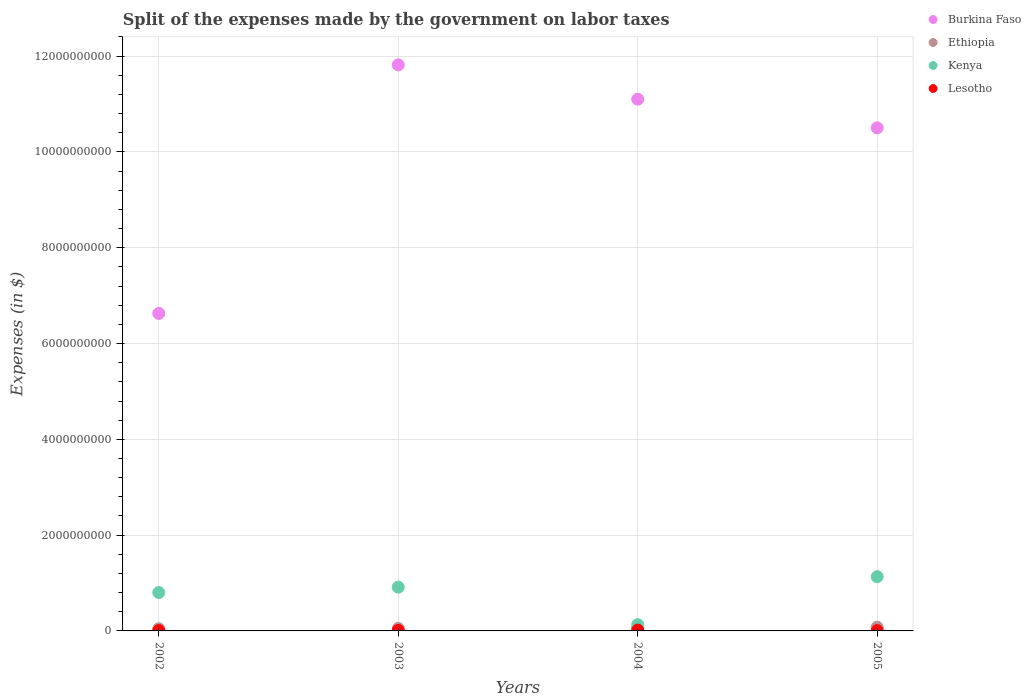How many different coloured dotlines are there?
Provide a short and direct response. 4. What is the expenses made by the government on labor taxes in Kenya in 2003?
Give a very brief answer. 9.14e+08. Across all years, what is the maximum expenses made by the government on labor taxes in Ethiopia?
Make the answer very short. 7.71e+07. Across all years, what is the minimum expenses made by the government on labor taxes in Burkina Faso?
Provide a succinct answer. 6.63e+09. In which year was the expenses made by the government on labor taxes in Ethiopia minimum?
Make the answer very short. 2002. What is the total expenses made by the government on labor taxes in Kenya in the graph?
Provide a succinct answer. 2.98e+09. What is the difference between the expenses made by the government on labor taxes in Ethiopia in 2003 and that in 2004?
Your response must be concise. -5.10e+06. What is the difference between the expenses made by the government on labor taxes in Ethiopia in 2002 and the expenses made by the government on labor taxes in Lesotho in 2003?
Give a very brief answer. 3.46e+07. What is the average expenses made by the government on labor taxes in Lesotho per year?
Your answer should be very brief. 1.04e+07. In the year 2003, what is the difference between the expenses made by the government on labor taxes in Ethiopia and expenses made by the government on labor taxes in Kenya?
Your answer should be very brief. -8.62e+08. In how many years, is the expenses made by the government on labor taxes in Lesotho greater than 1600000000 $?
Ensure brevity in your answer.  0. What is the ratio of the expenses made by the government on labor taxes in Lesotho in 2002 to that in 2005?
Your answer should be compact. 0.95. What is the difference between the highest and the lowest expenses made by the government on labor taxes in Burkina Faso?
Provide a succinct answer. 5.19e+09. In how many years, is the expenses made by the government on labor taxes in Lesotho greater than the average expenses made by the government on labor taxes in Lesotho taken over all years?
Provide a short and direct response. 2. Is it the case that in every year, the sum of the expenses made by the government on labor taxes in Kenya and expenses made by the government on labor taxes in Burkina Faso  is greater than the sum of expenses made by the government on labor taxes in Ethiopia and expenses made by the government on labor taxes in Lesotho?
Provide a succinct answer. Yes. Does the expenses made by the government on labor taxes in Lesotho monotonically increase over the years?
Give a very brief answer. No. Is the expenses made by the government on labor taxes in Kenya strictly less than the expenses made by the government on labor taxes in Lesotho over the years?
Your answer should be very brief. No. What is the difference between two consecutive major ticks on the Y-axis?
Offer a very short reply. 2.00e+09. Does the graph contain any zero values?
Give a very brief answer. No. How are the legend labels stacked?
Your answer should be very brief. Vertical. What is the title of the graph?
Your answer should be very brief. Split of the expenses made by the government on labor taxes. Does "Virgin Islands" appear as one of the legend labels in the graph?
Make the answer very short. No. What is the label or title of the X-axis?
Make the answer very short. Years. What is the label or title of the Y-axis?
Make the answer very short. Expenses (in $). What is the Expenses (in $) of Burkina Faso in 2002?
Ensure brevity in your answer.  6.63e+09. What is the Expenses (in $) of Ethiopia in 2002?
Provide a short and direct response. 4.51e+07. What is the Expenses (in $) in Kenya in 2002?
Offer a terse response. 8.01e+08. What is the Expenses (in $) in Lesotho in 2002?
Your response must be concise. 6.40e+06. What is the Expenses (in $) of Burkina Faso in 2003?
Provide a succinct answer. 1.18e+1. What is the Expenses (in $) in Ethiopia in 2003?
Your answer should be very brief. 5.20e+07. What is the Expenses (in $) of Kenya in 2003?
Your answer should be compact. 9.14e+08. What is the Expenses (in $) of Lesotho in 2003?
Your answer should be compact. 1.05e+07. What is the Expenses (in $) of Burkina Faso in 2004?
Ensure brevity in your answer.  1.11e+1. What is the Expenses (in $) of Ethiopia in 2004?
Provide a short and direct response. 5.71e+07. What is the Expenses (in $) of Kenya in 2004?
Your answer should be compact. 1.31e+08. What is the Expenses (in $) in Lesotho in 2004?
Provide a short and direct response. 1.78e+07. What is the Expenses (in $) in Burkina Faso in 2005?
Make the answer very short. 1.05e+1. What is the Expenses (in $) of Ethiopia in 2005?
Make the answer very short. 7.71e+07. What is the Expenses (in $) in Kenya in 2005?
Offer a terse response. 1.13e+09. What is the Expenses (in $) in Lesotho in 2005?
Provide a short and direct response. 6.74e+06. Across all years, what is the maximum Expenses (in $) of Burkina Faso?
Provide a short and direct response. 1.18e+1. Across all years, what is the maximum Expenses (in $) of Ethiopia?
Make the answer very short. 7.71e+07. Across all years, what is the maximum Expenses (in $) in Kenya?
Provide a short and direct response. 1.13e+09. Across all years, what is the maximum Expenses (in $) in Lesotho?
Offer a terse response. 1.78e+07. Across all years, what is the minimum Expenses (in $) of Burkina Faso?
Provide a succinct answer. 6.63e+09. Across all years, what is the minimum Expenses (in $) in Ethiopia?
Your answer should be compact. 4.51e+07. Across all years, what is the minimum Expenses (in $) in Kenya?
Give a very brief answer. 1.31e+08. Across all years, what is the minimum Expenses (in $) of Lesotho?
Give a very brief answer. 6.40e+06. What is the total Expenses (in $) of Burkina Faso in the graph?
Provide a succinct answer. 4.01e+1. What is the total Expenses (in $) of Ethiopia in the graph?
Offer a terse response. 2.31e+08. What is the total Expenses (in $) in Kenya in the graph?
Your answer should be very brief. 2.98e+09. What is the total Expenses (in $) in Lesotho in the graph?
Ensure brevity in your answer.  4.14e+07. What is the difference between the Expenses (in $) in Burkina Faso in 2002 and that in 2003?
Provide a short and direct response. -5.19e+09. What is the difference between the Expenses (in $) in Ethiopia in 2002 and that in 2003?
Provide a succinct answer. -6.90e+06. What is the difference between the Expenses (in $) of Kenya in 2002 and that in 2003?
Provide a succinct answer. -1.13e+08. What is the difference between the Expenses (in $) of Lesotho in 2002 and that in 2003?
Provide a short and direct response. -4.08e+06. What is the difference between the Expenses (in $) in Burkina Faso in 2002 and that in 2004?
Your answer should be compact. -4.47e+09. What is the difference between the Expenses (in $) of Ethiopia in 2002 and that in 2004?
Your answer should be very brief. -1.20e+07. What is the difference between the Expenses (in $) of Kenya in 2002 and that in 2004?
Ensure brevity in your answer.  6.70e+08. What is the difference between the Expenses (in $) in Lesotho in 2002 and that in 2004?
Give a very brief answer. -1.14e+07. What is the difference between the Expenses (in $) of Burkina Faso in 2002 and that in 2005?
Your answer should be compact. -3.88e+09. What is the difference between the Expenses (in $) in Ethiopia in 2002 and that in 2005?
Provide a succinct answer. -3.20e+07. What is the difference between the Expenses (in $) of Kenya in 2002 and that in 2005?
Ensure brevity in your answer.  -3.31e+08. What is the difference between the Expenses (in $) in Lesotho in 2002 and that in 2005?
Your response must be concise. -3.35e+05. What is the difference between the Expenses (in $) in Burkina Faso in 2003 and that in 2004?
Give a very brief answer. 7.17e+08. What is the difference between the Expenses (in $) in Ethiopia in 2003 and that in 2004?
Offer a terse response. -5.10e+06. What is the difference between the Expenses (in $) of Kenya in 2003 and that in 2004?
Your answer should be compact. 7.83e+08. What is the difference between the Expenses (in $) in Lesotho in 2003 and that in 2004?
Your response must be concise. -7.32e+06. What is the difference between the Expenses (in $) of Burkina Faso in 2003 and that in 2005?
Give a very brief answer. 1.31e+09. What is the difference between the Expenses (in $) of Ethiopia in 2003 and that in 2005?
Your answer should be compact. -2.51e+07. What is the difference between the Expenses (in $) of Kenya in 2003 and that in 2005?
Keep it short and to the point. -2.19e+08. What is the difference between the Expenses (in $) of Lesotho in 2003 and that in 2005?
Offer a very short reply. 3.74e+06. What is the difference between the Expenses (in $) of Burkina Faso in 2004 and that in 2005?
Offer a terse response. 5.98e+08. What is the difference between the Expenses (in $) of Ethiopia in 2004 and that in 2005?
Your response must be concise. -2.00e+07. What is the difference between the Expenses (in $) of Kenya in 2004 and that in 2005?
Give a very brief answer. -1.00e+09. What is the difference between the Expenses (in $) of Lesotho in 2004 and that in 2005?
Ensure brevity in your answer.  1.11e+07. What is the difference between the Expenses (in $) of Burkina Faso in 2002 and the Expenses (in $) of Ethiopia in 2003?
Your response must be concise. 6.58e+09. What is the difference between the Expenses (in $) in Burkina Faso in 2002 and the Expenses (in $) in Kenya in 2003?
Offer a terse response. 5.71e+09. What is the difference between the Expenses (in $) in Burkina Faso in 2002 and the Expenses (in $) in Lesotho in 2003?
Provide a short and direct response. 6.62e+09. What is the difference between the Expenses (in $) of Ethiopia in 2002 and the Expenses (in $) of Kenya in 2003?
Your answer should be compact. -8.69e+08. What is the difference between the Expenses (in $) of Ethiopia in 2002 and the Expenses (in $) of Lesotho in 2003?
Your response must be concise. 3.46e+07. What is the difference between the Expenses (in $) of Kenya in 2002 and the Expenses (in $) of Lesotho in 2003?
Ensure brevity in your answer.  7.90e+08. What is the difference between the Expenses (in $) in Burkina Faso in 2002 and the Expenses (in $) in Ethiopia in 2004?
Your answer should be very brief. 6.57e+09. What is the difference between the Expenses (in $) of Burkina Faso in 2002 and the Expenses (in $) of Kenya in 2004?
Make the answer very short. 6.50e+09. What is the difference between the Expenses (in $) in Burkina Faso in 2002 and the Expenses (in $) in Lesotho in 2004?
Your answer should be very brief. 6.61e+09. What is the difference between the Expenses (in $) in Ethiopia in 2002 and the Expenses (in $) in Kenya in 2004?
Keep it short and to the point. -8.59e+07. What is the difference between the Expenses (in $) in Ethiopia in 2002 and the Expenses (in $) in Lesotho in 2004?
Offer a terse response. 2.73e+07. What is the difference between the Expenses (in $) in Kenya in 2002 and the Expenses (in $) in Lesotho in 2004?
Offer a very short reply. 7.83e+08. What is the difference between the Expenses (in $) of Burkina Faso in 2002 and the Expenses (in $) of Ethiopia in 2005?
Give a very brief answer. 6.55e+09. What is the difference between the Expenses (in $) of Burkina Faso in 2002 and the Expenses (in $) of Kenya in 2005?
Provide a short and direct response. 5.50e+09. What is the difference between the Expenses (in $) in Burkina Faso in 2002 and the Expenses (in $) in Lesotho in 2005?
Give a very brief answer. 6.62e+09. What is the difference between the Expenses (in $) of Ethiopia in 2002 and the Expenses (in $) of Kenya in 2005?
Your answer should be very brief. -1.09e+09. What is the difference between the Expenses (in $) in Ethiopia in 2002 and the Expenses (in $) in Lesotho in 2005?
Give a very brief answer. 3.84e+07. What is the difference between the Expenses (in $) of Kenya in 2002 and the Expenses (in $) of Lesotho in 2005?
Keep it short and to the point. 7.94e+08. What is the difference between the Expenses (in $) of Burkina Faso in 2003 and the Expenses (in $) of Ethiopia in 2004?
Offer a terse response. 1.18e+1. What is the difference between the Expenses (in $) in Burkina Faso in 2003 and the Expenses (in $) in Kenya in 2004?
Ensure brevity in your answer.  1.17e+1. What is the difference between the Expenses (in $) of Burkina Faso in 2003 and the Expenses (in $) of Lesotho in 2004?
Your answer should be compact. 1.18e+1. What is the difference between the Expenses (in $) in Ethiopia in 2003 and the Expenses (in $) in Kenya in 2004?
Your answer should be compact. -7.90e+07. What is the difference between the Expenses (in $) of Ethiopia in 2003 and the Expenses (in $) of Lesotho in 2004?
Your answer should be compact. 3.42e+07. What is the difference between the Expenses (in $) in Kenya in 2003 and the Expenses (in $) in Lesotho in 2004?
Provide a short and direct response. 8.96e+08. What is the difference between the Expenses (in $) of Burkina Faso in 2003 and the Expenses (in $) of Ethiopia in 2005?
Provide a short and direct response. 1.17e+1. What is the difference between the Expenses (in $) of Burkina Faso in 2003 and the Expenses (in $) of Kenya in 2005?
Provide a short and direct response. 1.07e+1. What is the difference between the Expenses (in $) in Burkina Faso in 2003 and the Expenses (in $) in Lesotho in 2005?
Your response must be concise. 1.18e+1. What is the difference between the Expenses (in $) in Ethiopia in 2003 and the Expenses (in $) in Kenya in 2005?
Provide a succinct answer. -1.08e+09. What is the difference between the Expenses (in $) in Ethiopia in 2003 and the Expenses (in $) in Lesotho in 2005?
Provide a succinct answer. 4.53e+07. What is the difference between the Expenses (in $) of Kenya in 2003 and the Expenses (in $) of Lesotho in 2005?
Ensure brevity in your answer.  9.07e+08. What is the difference between the Expenses (in $) of Burkina Faso in 2004 and the Expenses (in $) of Ethiopia in 2005?
Offer a terse response. 1.10e+1. What is the difference between the Expenses (in $) in Burkina Faso in 2004 and the Expenses (in $) in Kenya in 2005?
Your response must be concise. 9.97e+09. What is the difference between the Expenses (in $) in Burkina Faso in 2004 and the Expenses (in $) in Lesotho in 2005?
Your answer should be compact. 1.11e+1. What is the difference between the Expenses (in $) in Ethiopia in 2004 and the Expenses (in $) in Kenya in 2005?
Give a very brief answer. -1.08e+09. What is the difference between the Expenses (in $) in Ethiopia in 2004 and the Expenses (in $) in Lesotho in 2005?
Your answer should be very brief. 5.04e+07. What is the difference between the Expenses (in $) of Kenya in 2004 and the Expenses (in $) of Lesotho in 2005?
Give a very brief answer. 1.24e+08. What is the average Expenses (in $) in Burkina Faso per year?
Make the answer very short. 1.00e+1. What is the average Expenses (in $) in Ethiopia per year?
Make the answer very short. 5.78e+07. What is the average Expenses (in $) of Kenya per year?
Your answer should be compact. 7.44e+08. What is the average Expenses (in $) of Lesotho per year?
Make the answer very short. 1.04e+07. In the year 2002, what is the difference between the Expenses (in $) in Burkina Faso and Expenses (in $) in Ethiopia?
Give a very brief answer. 6.58e+09. In the year 2002, what is the difference between the Expenses (in $) of Burkina Faso and Expenses (in $) of Kenya?
Ensure brevity in your answer.  5.83e+09. In the year 2002, what is the difference between the Expenses (in $) of Burkina Faso and Expenses (in $) of Lesotho?
Make the answer very short. 6.62e+09. In the year 2002, what is the difference between the Expenses (in $) of Ethiopia and Expenses (in $) of Kenya?
Your answer should be very brief. -7.56e+08. In the year 2002, what is the difference between the Expenses (in $) of Ethiopia and Expenses (in $) of Lesotho?
Offer a terse response. 3.87e+07. In the year 2002, what is the difference between the Expenses (in $) in Kenya and Expenses (in $) in Lesotho?
Your answer should be very brief. 7.95e+08. In the year 2003, what is the difference between the Expenses (in $) in Burkina Faso and Expenses (in $) in Ethiopia?
Keep it short and to the point. 1.18e+1. In the year 2003, what is the difference between the Expenses (in $) in Burkina Faso and Expenses (in $) in Kenya?
Offer a very short reply. 1.09e+1. In the year 2003, what is the difference between the Expenses (in $) of Burkina Faso and Expenses (in $) of Lesotho?
Your answer should be very brief. 1.18e+1. In the year 2003, what is the difference between the Expenses (in $) in Ethiopia and Expenses (in $) in Kenya?
Your answer should be very brief. -8.62e+08. In the year 2003, what is the difference between the Expenses (in $) in Ethiopia and Expenses (in $) in Lesotho?
Your answer should be compact. 4.15e+07. In the year 2003, what is the difference between the Expenses (in $) in Kenya and Expenses (in $) in Lesotho?
Your response must be concise. 9.03e+08. In the year 2004, what is the difference between the Expenses (in $) in Burkina Faso and Expenses (in $) in Ethiopia?
Your answer should be compact. 1.10e+1. In the year 2004, what is the difference between the Expenses (in $) in Burkina Faso and Expenses (in $) in Kenya?
Your answer should be compact. 1.10e+1. In the year 2004, what is the difference between the Expenses (in $) of Burkina Faso and Expenses (in $) of Lesotho?
Make the answer very short. 1.11e+1. In the year 2004, what is the difference between the Expenses (in $) of Ethiopia and Expenses (in $) of Kenya?
Ensure brevity in your answer.  -7.39e+07. In the year 2004, what is the difference between the Expenses (in $) in Ethiopia and Expenses (in $) in Lesotho?
Your answer should be compact. 3.93e+07. In the year 2004, what is the difference between the Expenses (in $) of Kenya and Expenses (in $) of Lesotho?
Offer a terse response. 1.13e+08. In the year 2005, what is the difference between the Expenses (in $) of Burkina Faso and Expenses (in $) of Ethiopia?
Your answer should be compact. 1.04e+1. In the year 2005, what is the difference between the Expenses (in $) in Burkina Faso and Expenses (in $) in Kenya?
Provide a succinct answer. 9.37e+09. In the year 2005, what is the difference between the Expenses (in $) of Burkina Faso and Expenses (in $) of Lesotho?
Provide a short and direct response. 1.05e+1. In the year 2005, what is the difference between the Expenses (in $) of Ethiopia and Expenses (in $) of Kenya?
Make the answer very short. -1.06e+09. In the year 2005, what is the difference between the Expenses (in $) in Ethiopia and Expenses (in $) in Lesotho?
Your answer should be compact. 7.04e+07. In the year 2005, what is the difference between the Expenses (in $) in Kenya and Expenses (in $) in Lesotho?
Your answer should be compact. 1.13e+09. What is the ratio of the Expenses (in $) in Burkina Faso in 2002 to that in 2003?
Your answer should be compact. 0.56. What is the ratio of the Expenses (in $) of Ethiopia in 2002 to that in 2003?
Offer a terse response. 0.87. What is the ratio of the Expenses (in $) in Kenya in 2002 to that in 2003?
Provide a succinct answer. 0.88. What is the ratio of the Expenses (in $) of Lesotho in 2002 to that in 2003?
Your answer should be compact. 0.61. What is the ratio of the Expenses (in $) in Burkina Faso in 2002 to that in 2004?
Make the answer very short. 0.6. What is the ratio of the Expenses (in $) in Ethiopia in 2002 to that in 2004?
Keep it short and to the point. 0.79. What is the ratio of the Expenses (in $) of Kenya in 2002 to that in 2004?
Ensure brevity in your answer.  6.11. What is the ratio of the Expenses (in $) of Lesotho in 2002 to that in 2004?
Your answer should be compact. 0.36. What is the ratio of the Expenses (in $) in Burkina Faso in 2002 to that in 2005?
Your response must be concise. 0.63. What is the ratio of the Expenses (in $) in Ethiopia in 2002 to that in 2005?
Give a very brief answer. 0.58. What is the ratio of the Expenses (in $) in Kenya in 2002 to that in 2005?
Provide a short and direct response. 0.71. What is the ratio of the Expenses (in $) of Lesotho in 2002 to that in 2005?
Ensure brevity in your answer.  0.95. What is the ratio of the Expenses (in $) of Burkina Faso in 2003 to that in 2004?
Give a very brief answer. 1.06. What is the ratio of the Expenses (in $) in Ethiopia in 2003 to that in 2004?
Your answer should be compact. 0.91. What is the ratio of the Expenses (in $) of Kenya in 2003 to that in 2004?
Offer a very short reply. 6.97. What is the ratio of the Expenses (in $) in Lesotho in 2003 to that in 2004?
Give a very brief answer. 0.59. What is the ratio of the Expenses (in $) of Burkina Faso in 2003 to that in 2005?
Give a very brief answer. 1.13. What is the ratio of the Expenses (in $) in Ethiopia in 2003 to that in 2005?
Your answer should be compact. 0.67. What is the ratio of the Expenses (in $) in Kenya in 2003 to that in 2005?
Provide a succinct answer. 0.81. What is the ratio of the Expenses (in $) of Lesotho in 2003 to that in 2005?
Your answer should be compact. 1.56. What is the ratio of the Expenses (in $) of Burkina Faso in 2004 to that in 2005?
Your response must be concise. 1.06. What is the ratio of the Expenses (in $) of Ethiopia in 2004 to that in 2005?
Give a very brief answer. 0.74. What is the ratio of the Expenses (in $) in Kenya in 2004 to that in 2005?
Offer a very short reply. 0.12. What is the ratio of the Expenses (in $) of Lesotho in 2004 to that in 2005?
Offer a terse response. 2.64. What is the difference between the highest and the second highest Expenses (in $) of Burkina Faso?
Keep it short and to the point. 7.17e+08. What is the difference between the highest and the second highest Expenses (in $) of Ethiopia?
Your response must be concise. 2.00e+07. What is the difference between the highest and the second highest Expenses (in $) of Kenya?
Offer a terse response. 2.19e+08. What is the difference between the highest and the second highest Expenses (in $) in Lesotho?
Keep it short and to the point. 7.32e+06. What is the difference between the highest and the lowest Expenses (in $) of Burkina Faso?
Your answer should be very brief. 5.19e+09. What is the difference between the highest and the lowest Expenses (in $) of Ethiopia?
Keep it short and to the point. 3.20e+07. What is the difference between the highest and the lowest Expenses (in $) of Kenya?
Ensure brevity in your answer.  1.00e+09. What is the difference between the highest and the lowest Expenses (in $) of Lesotho?
Give a very brief answer. 1.14e+07. 